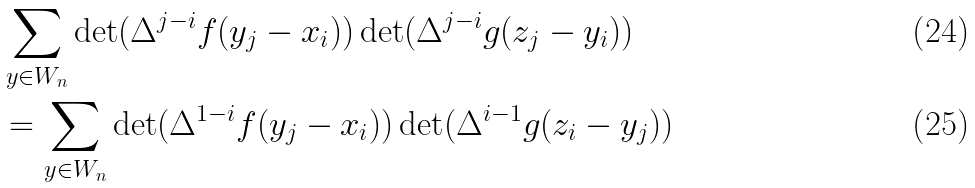Convert formula to latex. <formula><loc_0><loc_0><loc_500><loc_500>& \sum _ { y \in W _ { n } } \det ( \Delta ^ { j - i } f ( y _ { j } - x _ { i } ) ) \det ( \Delta ^ { j - i } g ( z _ { j } - y _ { i } ) ) \\ & = \sum _ { y \in W _ { n } } \det ( \Delta ^ { 1 - i } f ( y _ { j } - x _ { i } ) ) \det ( \Delta ^ { i - 1 } g ( z _ { i } - y _ { j } ) )</formula> 